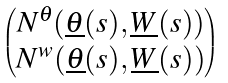<formula> <loc_0><loc_0><loc_500><loc_500>\begin{pmatrix} N ^ { \theta } ( \underline { \theta } ( s ) , \underline { W } ( s ) ) \\ N ^ { w } ( \underline { \theta } ( s ) , \underline { W } ( s ) ) \end{pmatrix}</formula> 